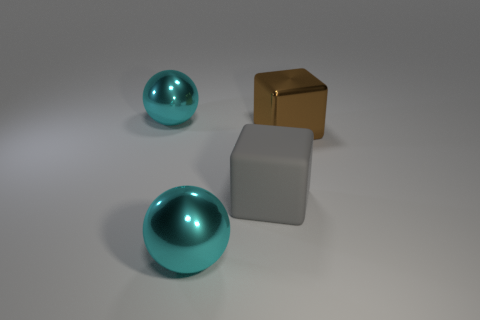Add 2 rubber things. How many objects exist? 6 Subtract 0 red cubes. How many objects are left? 4 Subtract all gray rubber blocks. Subtract all big blue rubber cylinders. How many objects are left? 3 Add 1 cyan metallic spheres. How many cyan metallic spheres are left? 3 Add 4 big cubes. How many big cubes exist? 6 